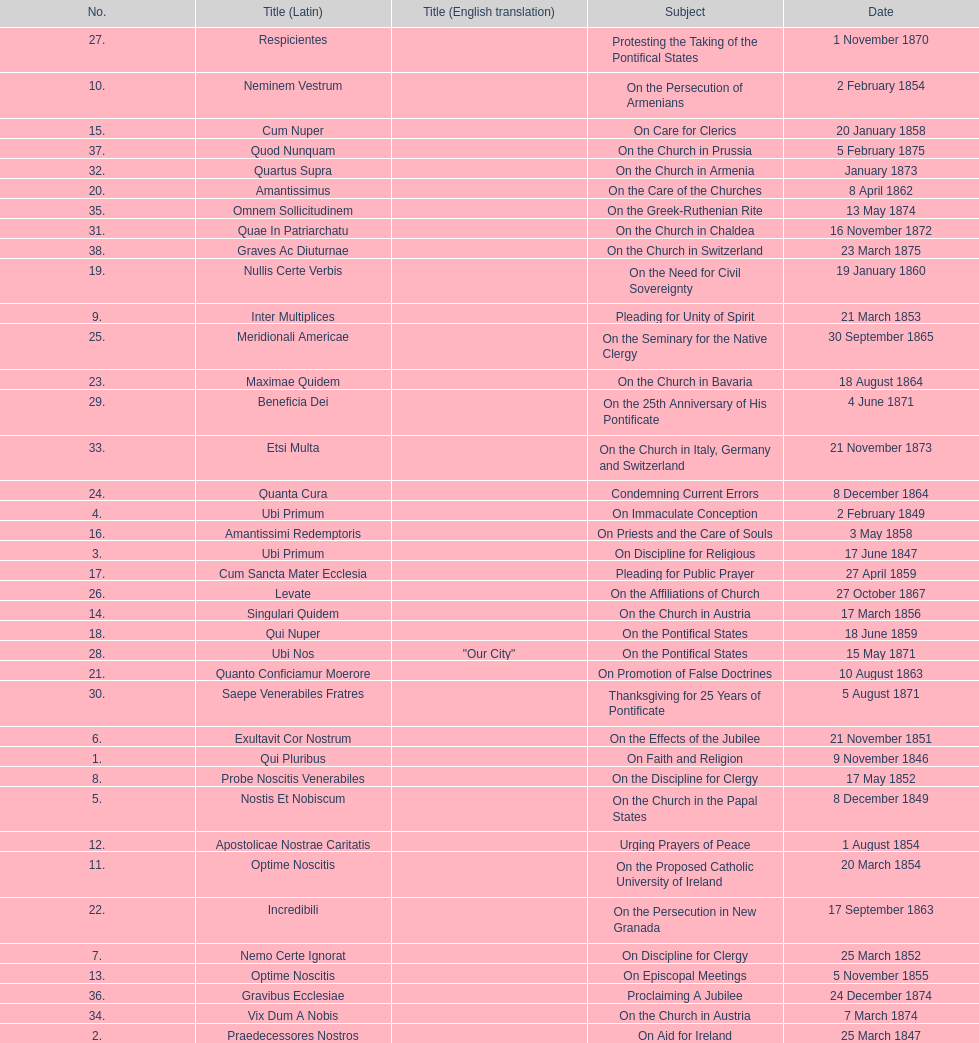What is the total number of title? 38. 